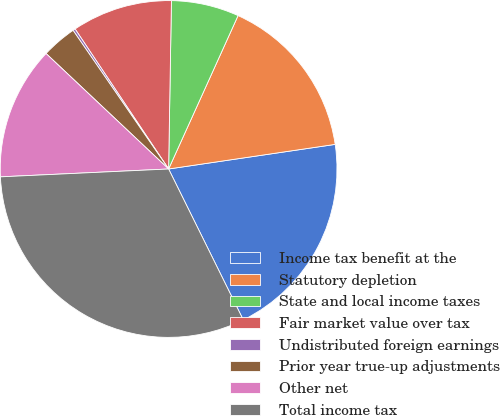Convert chart to OTSL. <chart><loc_0><loc_0><loc_500><loc_500><pie_chart><fcel>Income tax benefit at the<fcel>Statutory depletion<fcel>State and local income taxes<fcel>Fair market value over tax<fcel>Undistributed foreign earnings<fcel>Prior year true-up adjustments<fcel>Other net<fcel>Total income tax<nl><fcel>20.02%<fcel>15.9%<fcel>6.5%<fcel>9.64%<fcel>0.23%<fcel>3.37%<fcel>12.77%<fcel>31.57%<nl></chart> 